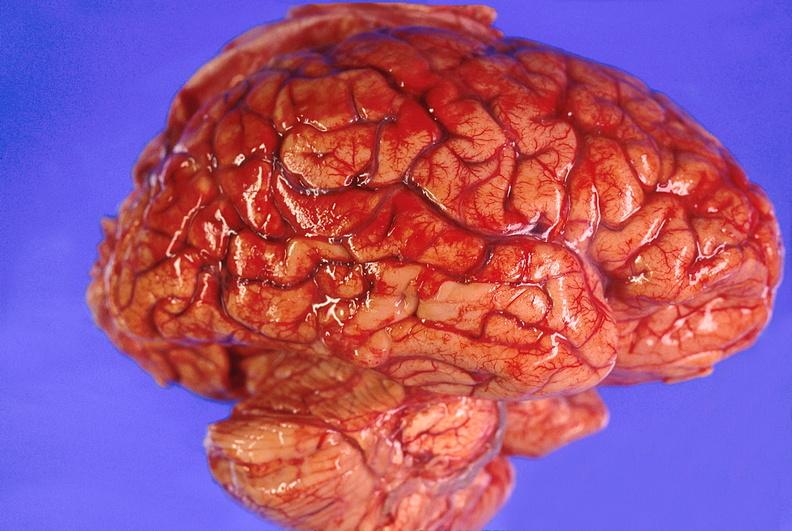does saggital section typical show brain abscess?
Answer the question using a single word or phrase. No 